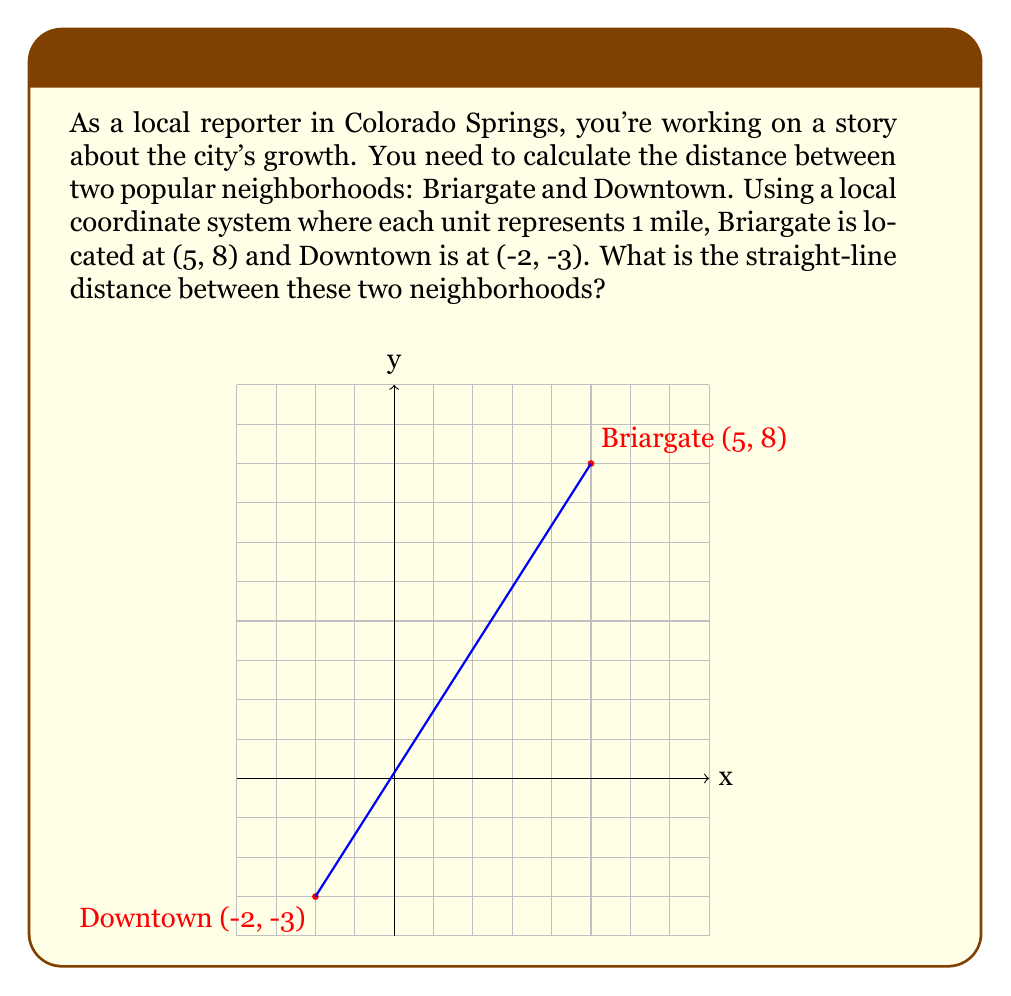Help me with this question. To calculate the straight-line distance between two points in a coordinate system, we can use the distance formula, which is derived from the Pythagorean theorem:

$$d = \sqrt{(x_2 - x_1)^2 + (y_2 - y_1)^2}$$

Where $(x_1, y_1)$ represents the coordinates of the first point and $(x_2, y_2)$ represents the coordinates of the second point.

Let's plug in our values:
- Briargate: $(x_1, y_1) = (5, 8)$
- Downtown: $(x_2, y_2) = (-2, -3)$

Now, let's calculate step by step:

1) $d = \sqrt{(-2 - 5)^2 + (-3 - 8)^2}$

2) $d = \sqrt{(-7)^2 + (-11)^2}$

3) $d = \sqrt{49 + 121}$

4) $d = \sqrt{170}$

5) $d \approx 13.04$ miles

Therefore, the straight-line distance between Briargate and Downtown is approximately 13.04 miles.
Answer: $13.04$ miles 